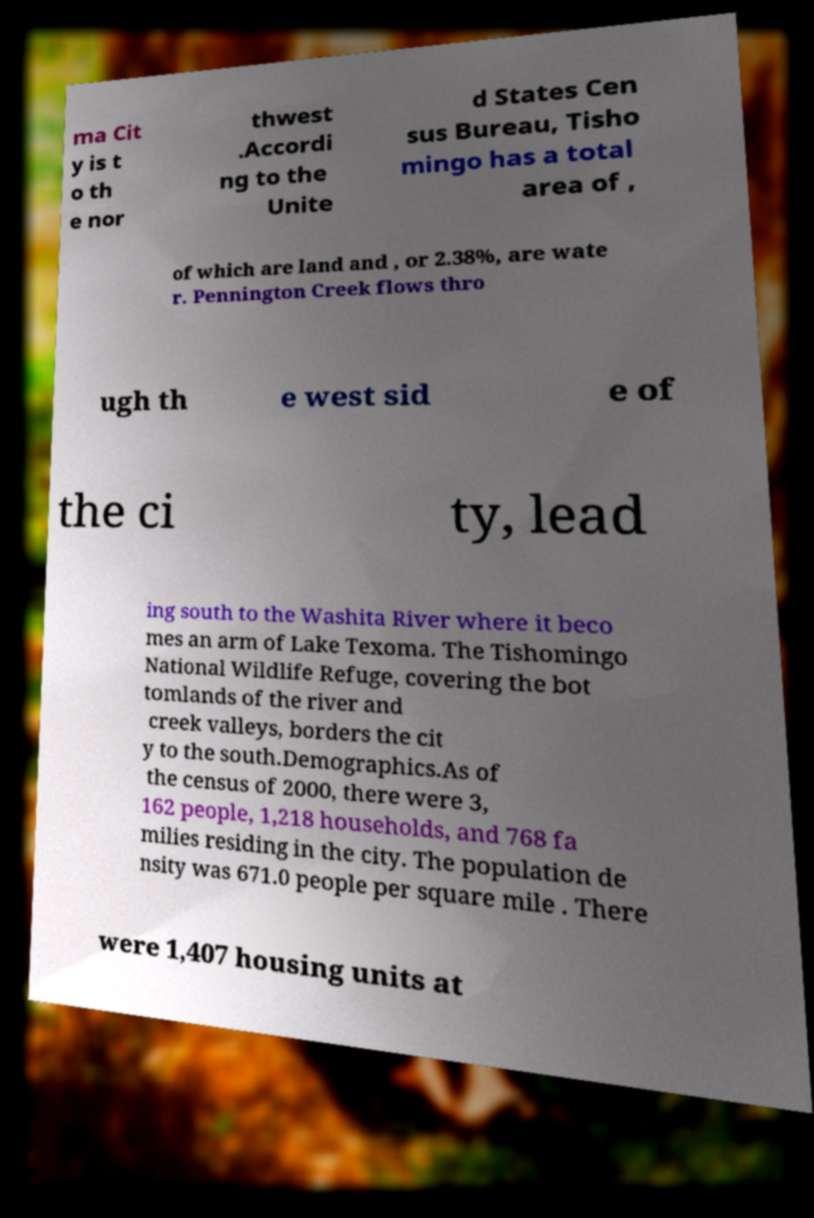Could you extract and type out the text from this image? ma Cit y is t o th e nor thwest .Accordi ng to the Unite d States Cen sus Bureau, Tisho mingo has a total area of , of which are land and , or 2.38%, are wate r. Pennington Creek flows thro ugh th e west sid e of the ci ty, lead ing south to the Washita River where it beco mes an arm of Lake Texoma. The Tishomingo National Wildlife Refuge, covering the bot tomlands of the river and creek valleys, borders the cit y to the south.Demographics.As of the census of 2000, there were 3, 162 people, 1,218 households, and 768 fa milies residing in the city. The population de nsity was 671.0 people per square mile . There were 1,407 housing units at 